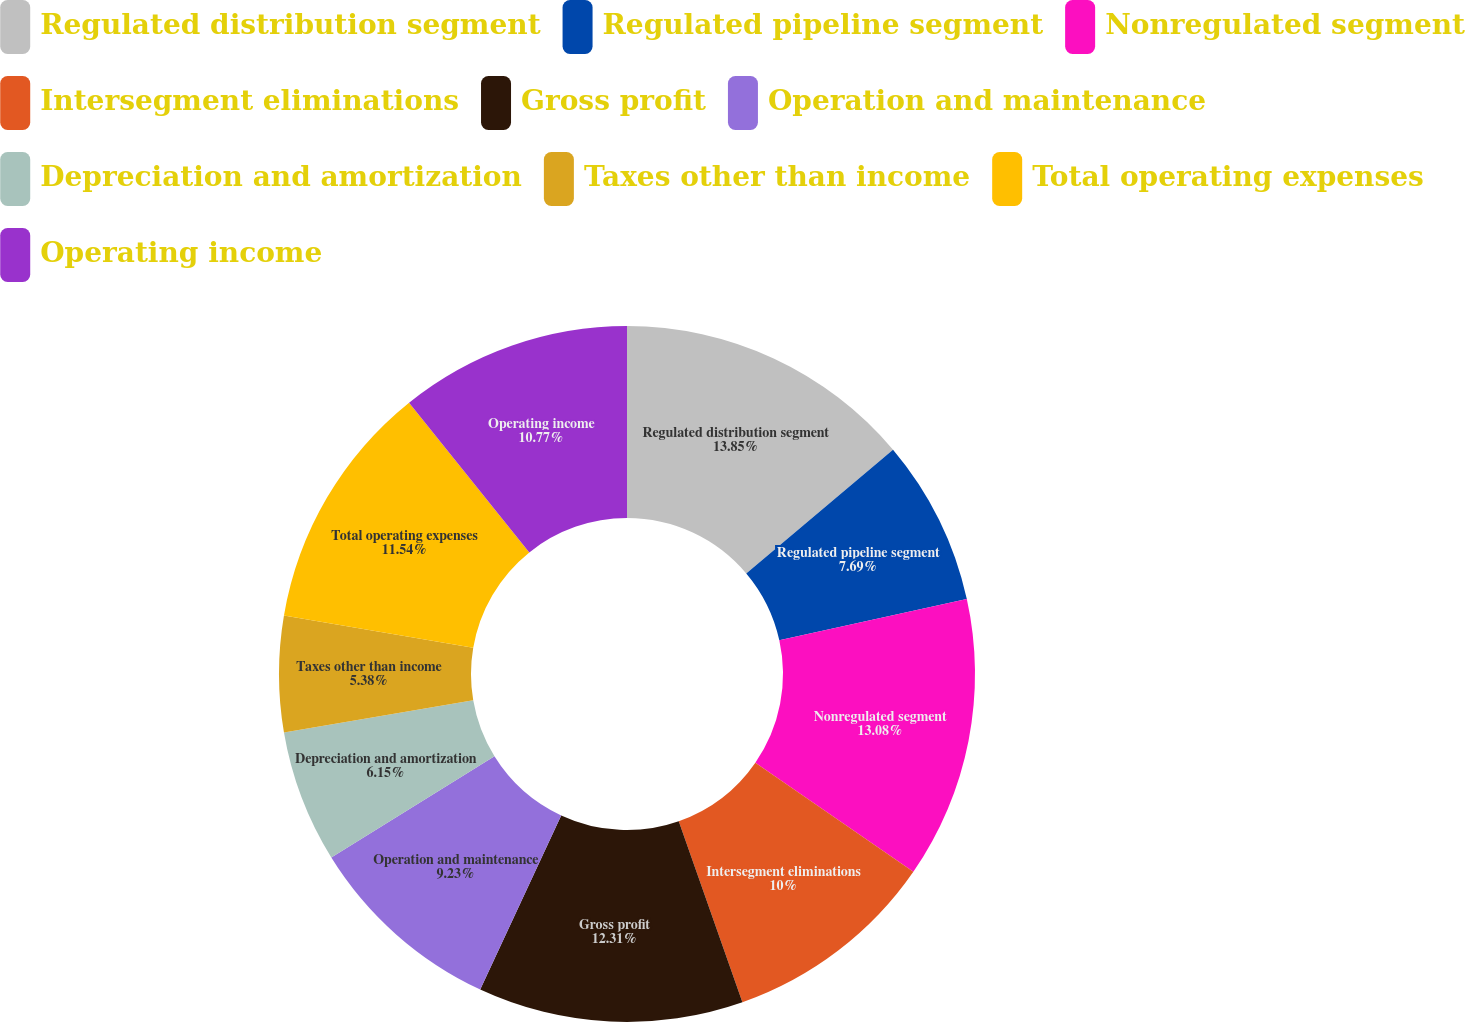Convert chart to OTSL. <chart><loc_0><loc_0><loc_500><loc_500><pie_chart><fcel>Regulated distribution segment<fcel>Regulated pipeline segment<fcel>Nonregulated segment<fcel>Intersegment eliminations<fcel>Gross profit<fcel>Operation and maintenance<fcel>Depreciation and amortization<fcel>Taxes other than income<fcel>Total operating expenses<fcel>Operating income<nl><fcel>13.85%<fcel>7.69%<fcel>13.08%<fcel>10.0%<fcel>12.31%<fcel>9.23%<fcel>6.15%<fcel>5.38%<fcel>11.54%<fcel>10.77%<nl></chart> 